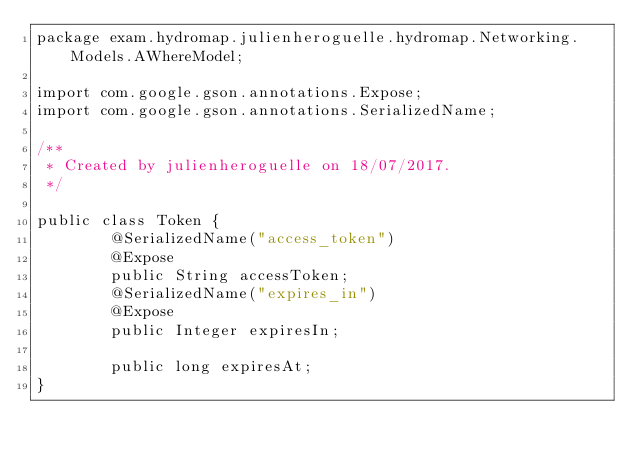<code> <loc_0><loc_0><loc_500><loc_500><_Java_>package exam.hydromap.julienheroguelle.hydromap.Networking.Models.AWhereModel;

import com.google.gson.annotations.Expose;
import com.google.gson.annotations.SerializedName;

/**
 * Created by julienheroguelle on 18/07/2017.
 */

public class Token {
        @SerializedName("access_token")
        @Expose
        public String accessToken;
        @SerializedName("expires_in")
        @Expose
        public Integer expiresIn;

        public long expiresAt;
}</code> 